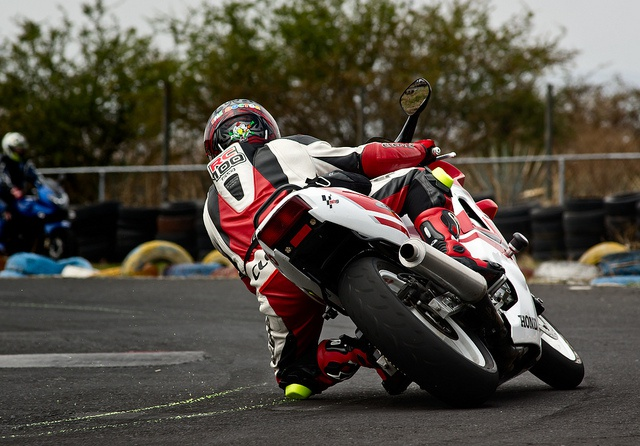Describe the objects in this image and their specific colors. I can see motorcycle in lightgray, black, gray, and darkgray tones, people in lightgray, black, white, gray, and maroon tones, motorcycle in lightgray, black, gray, navy, and blue tones, and people in lightgray, black, gray, and darkgray tones in this image. 